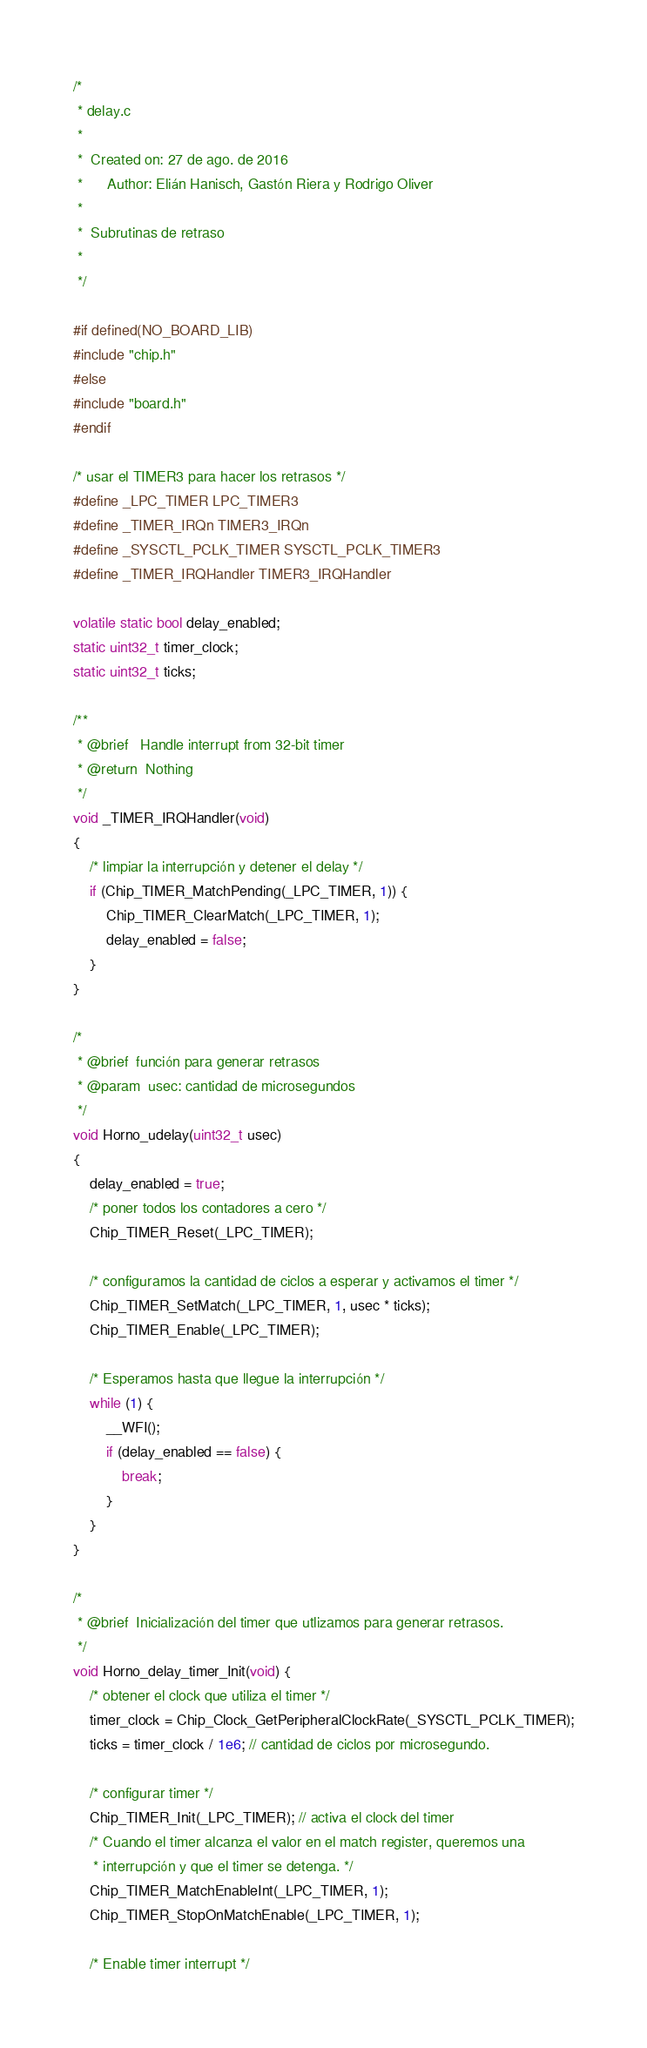Convert code to text. <code><loc_0><loc_0><loc_500><loc_500><_C_>/*
 * delay.c
 *
 *  Created on: 27 de ago. de 2016
 *      Author: Elián Hanisch, Gastón Riera y Rodrigo Oliver
 *
 *  Subrutinas de retraso
 *
 */

#if defined(NO_BOARD_LIB)
#include "chip.h"
#else
#include "board.h"
#endif

/* usar el TIMER3 para hacer los retrasos */
#define _LPC_TIMER LPC_TIMER3
#define _TIMER_IRQn TIMER3_IRQn
#define _SYSCTL_PCLK_TIMER SYSCTL_PCLK_TIMER3
#define _TIMER_IRQHandler TIMER3_IRQHandler

volatile static bool delay_enabled;
static uint32_t timer_clock;
static uint32_t ticks;

/**
 * @brief	Handle interrupt from 32-bit timer
 * @return	Nothing
 */
void _TIMER_IRQHandler(void)
{
	/* limpiar la interrupción y detener el delay */
	if (Chip_TIMER_MatchPending(_LPC_TIMER, 1)) {
		Chip_TIMER_ClearMatch(_LPC_TIMER, 1);
		delay_enabled = false;
	}
}

/*
 * @brief  función para generar retrasos
 * @param  usec: cantidad de microsegundos
 */
void Horno_udelay(uint32_t usec)
{
	delay_enabled = true;
	/* poner todos los contadores a cero */
	Chip_TIMER_Reset(_LPC_TIMER);

	/* configuramos la cantidad de ciclos a esperar y activamos el timer */
	Chip_TIMER_SetMatch(_LPC_TIMER, 1, usec * ticks);
	Chip_TIMER_Enable(_LPC_TIMER);

	/* Esperamos hasta que llegue la interrupción */
	while (1) {
		__WFI();
		if (delay_enabled == false) {
			break;
		}
	}
}

/*
 * @brief  Inicialización del timer que utlizamos para generar retrasos.
 */
void Horno_delay_timer_Init(void) {
	/* obtener el clock que utiliza el timer */
	timer_clock = Chip_Clock_GetPeripheralClockRate(_SYSCTL_PCLK_TIMER);
	ticks = timer_clock / 1e6; // cantidad de ciclos por microsegundo.

	/* configurar timer */
	Chip_TIMER_Init(_LPC_TIMER); // activa el clock del timer
	/* Cuando el timer alcanza el valor en el match register, queremos una
	 * interrupción y que el timer se detenga. */
	Chip_TIMER_MatchEnableInt(_LPC_TIMER, 1);
	Chip_TIMER_StopOnMatchEnable(_LPC_TIMER, 1);

	/* Enable timer interrupt */</code> 